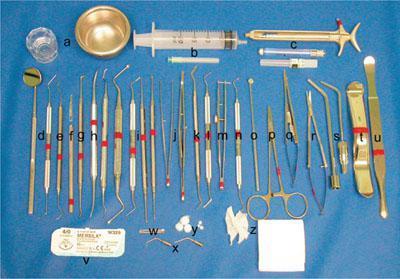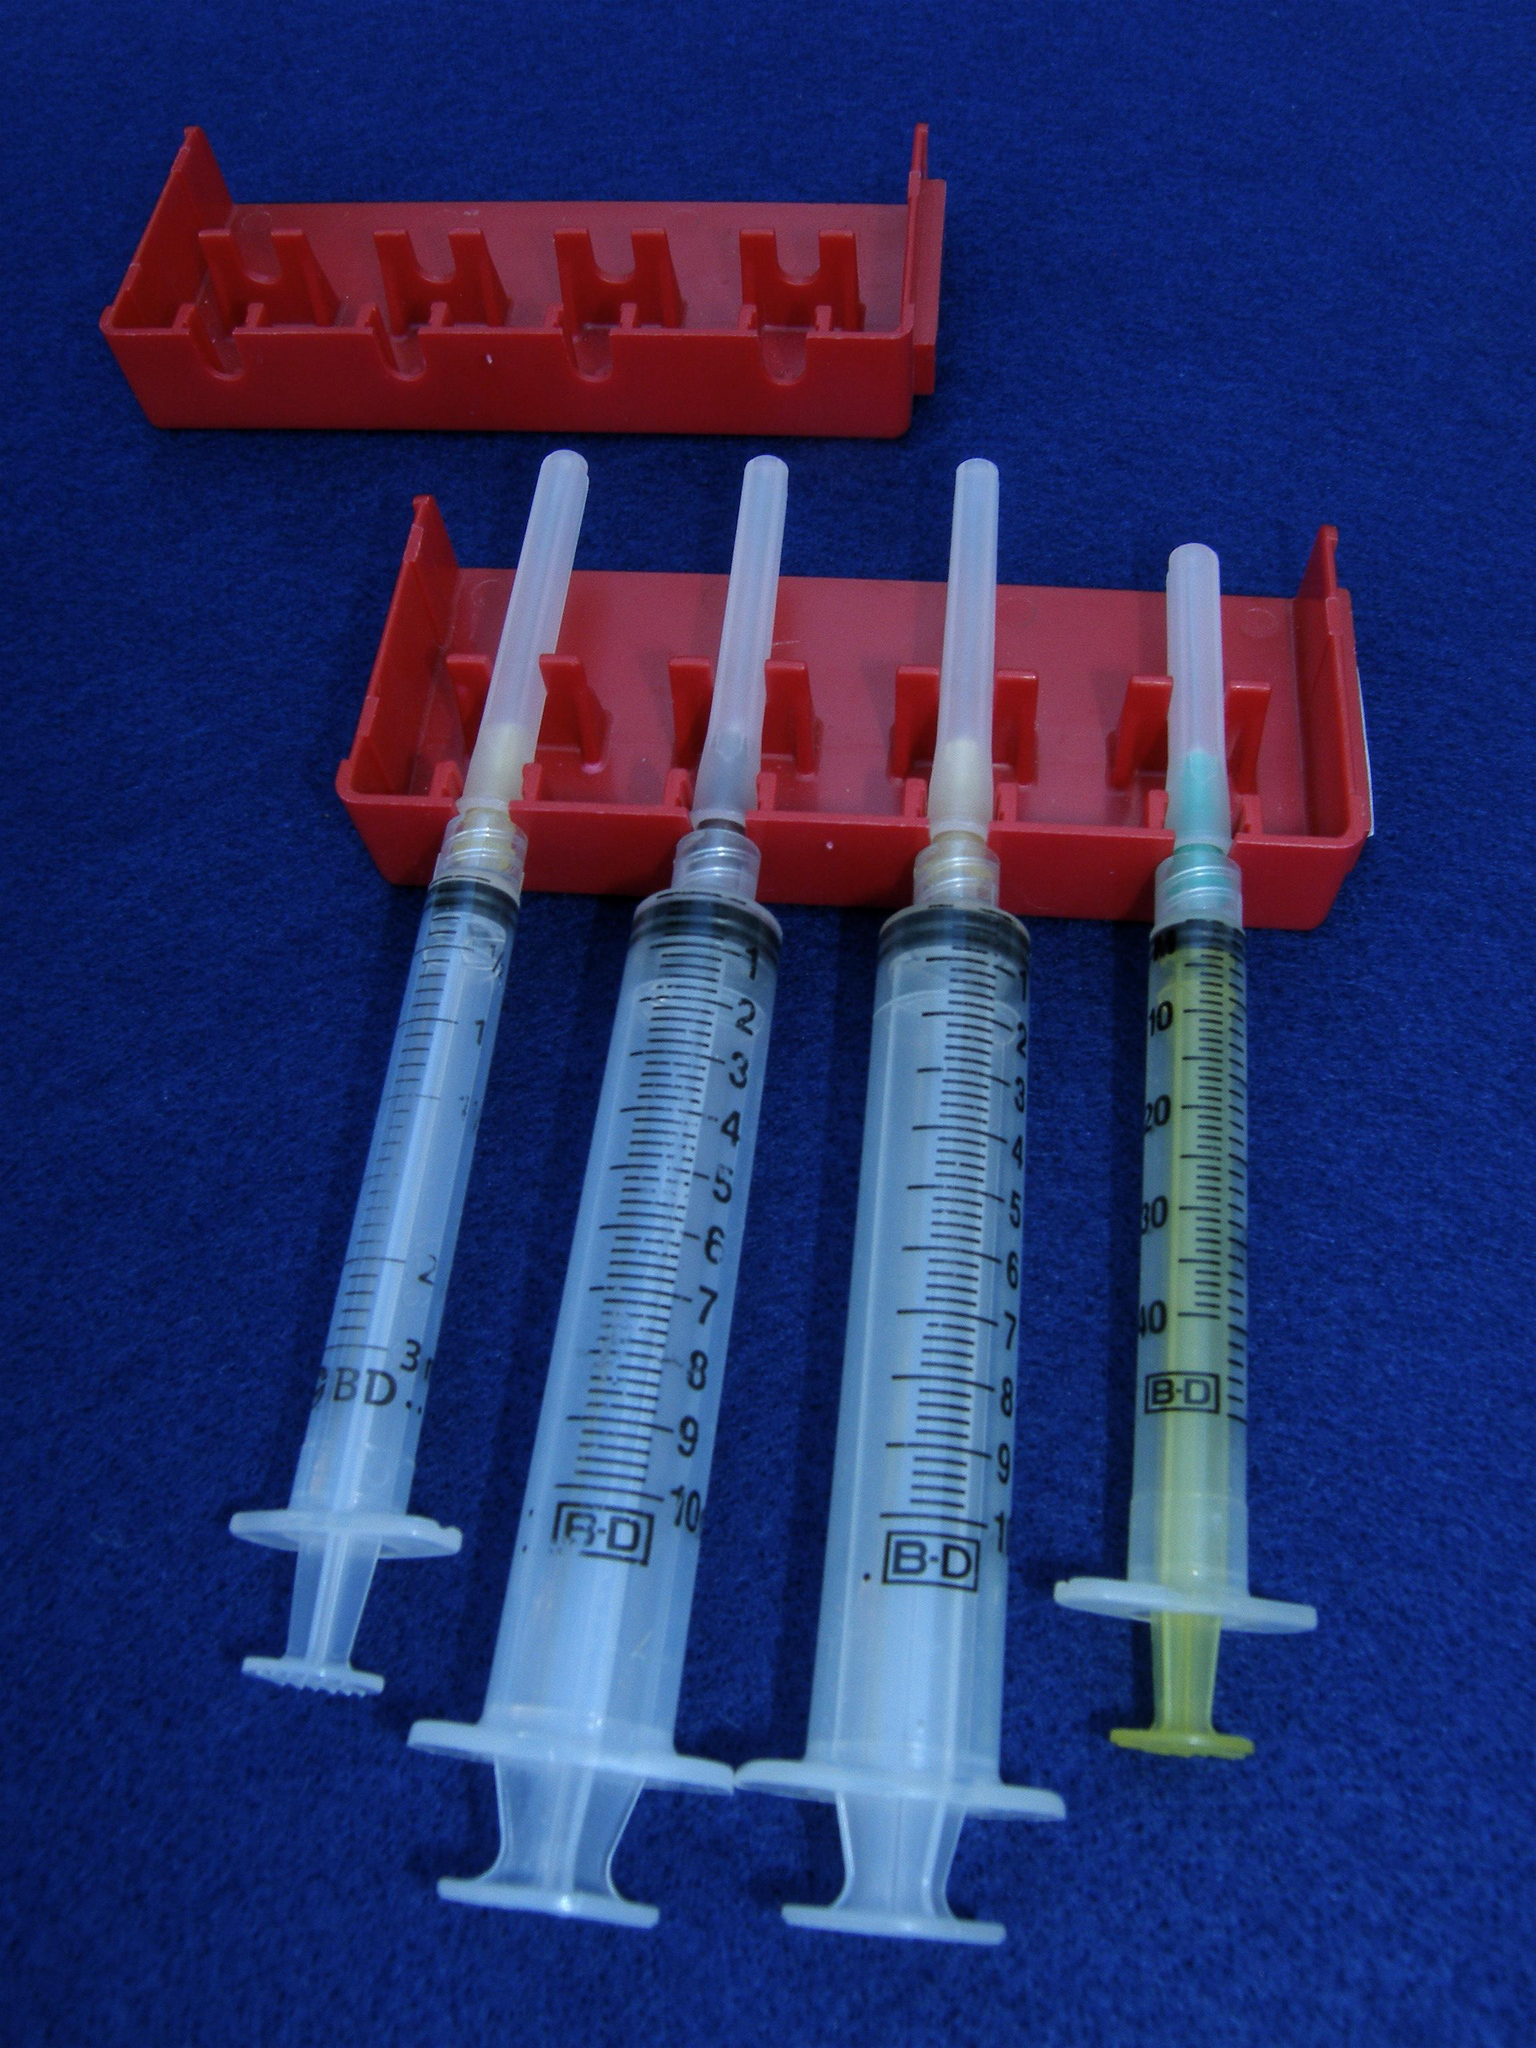The first image is the image on the left, the second image is the image on the right. Assess this claim about the two images: "At least one orange cap is visible in the image on the left.". Correct or not? Answer yes or no. No. 